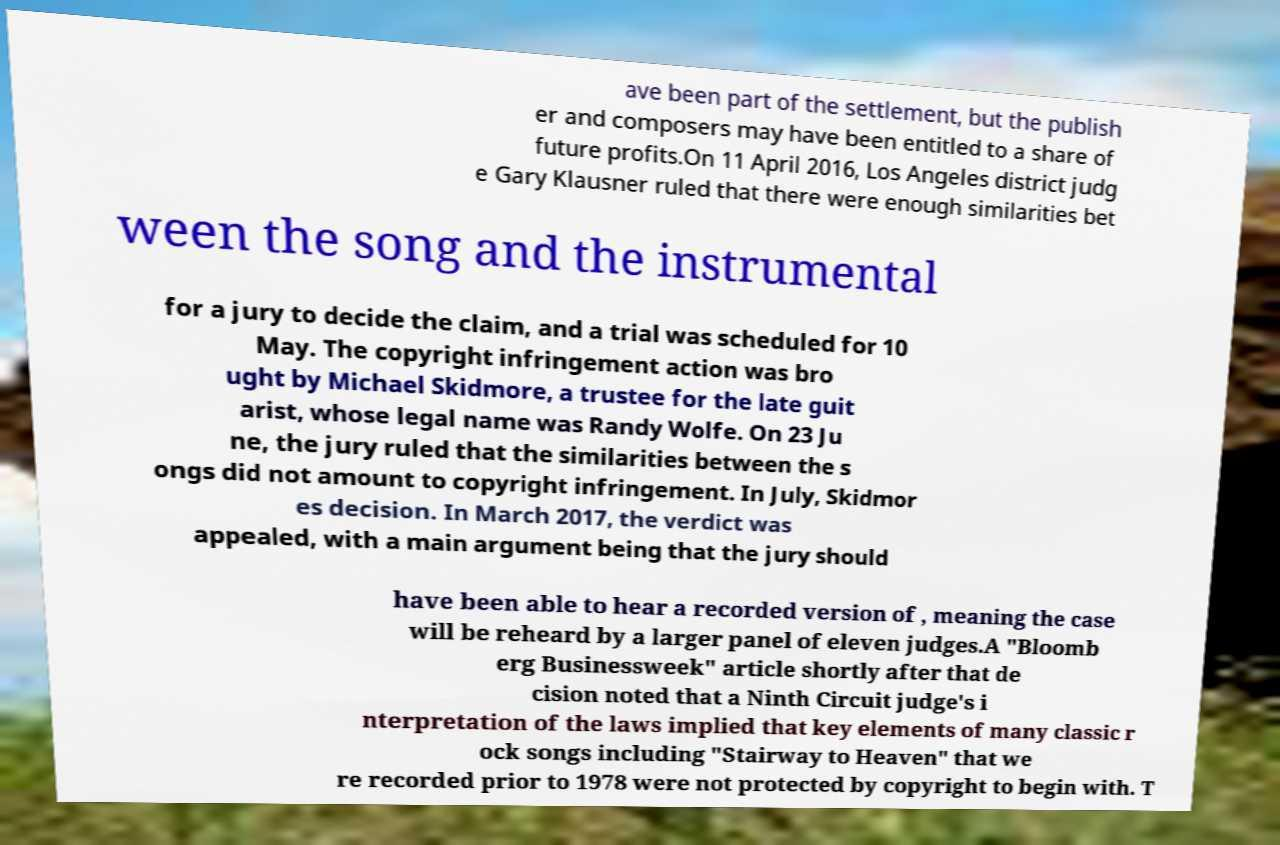Can you read and provide the text displayed in the image?This photo seems to have some interesting text. Can you extract and type it out for me? ave been part of the settlement, but the publish er and composers may have been entitled to a share of future profits.On 11 April 2016, Los Angeles district judg e Gary Klausner ruled that there were enough similarities bet ween the song and the instrumental for a jury to decide the claim, and a trial was scheduled for 10 May. The copyright infringement action was bro ught by Michael Skidmore, a trustee for the late guit arist, whose legal name was Randy Wolfe. On 23 Ju ne, the jury ruled that the similarities between the s ongs did not amount to copyright infringement. In July, Skidmor es decision. In March 2017, the verdict was appealed, with a main argument being that the jury should have been able to hear a recorded version of , meaning the case will be reheard by a larger panel of eleven judges.A "Bloomb erg Businessweek" article shortly after that de cision noted that a Ninth Circuit judge's i nterpretation of the laws implied that key elements of many classic r ock songs including "Stairway to Heaven" that we re recorded prior to 1978 were not protected by copyright to begin with. T 